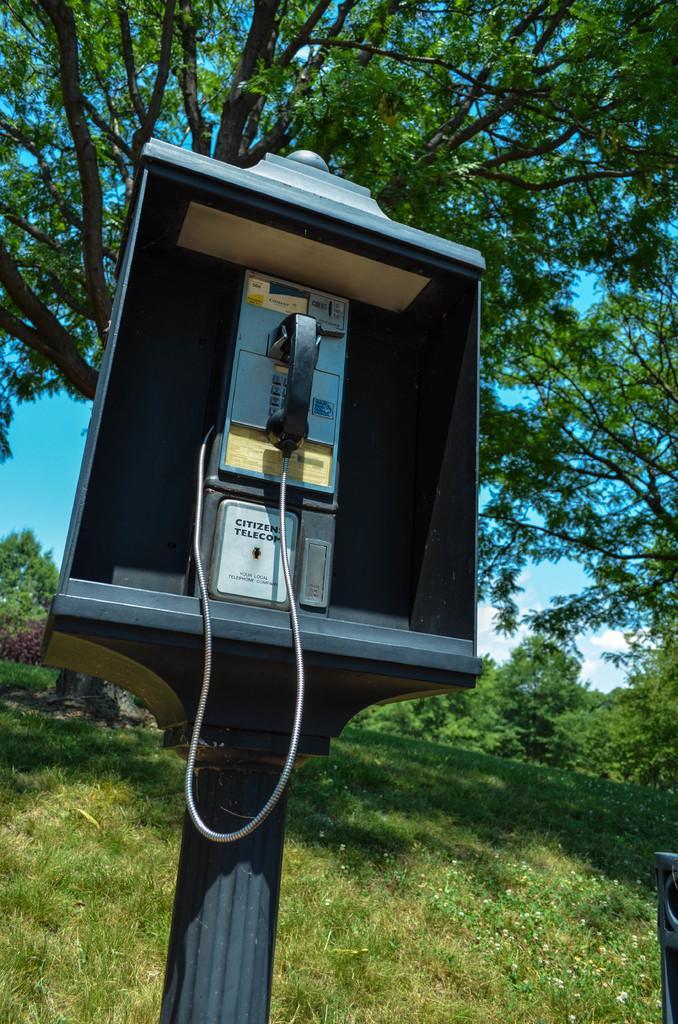Describe this image in one or two sentences. In this picture I can see a telephone booth with a pole, there are trees, and in the background there is sky. 